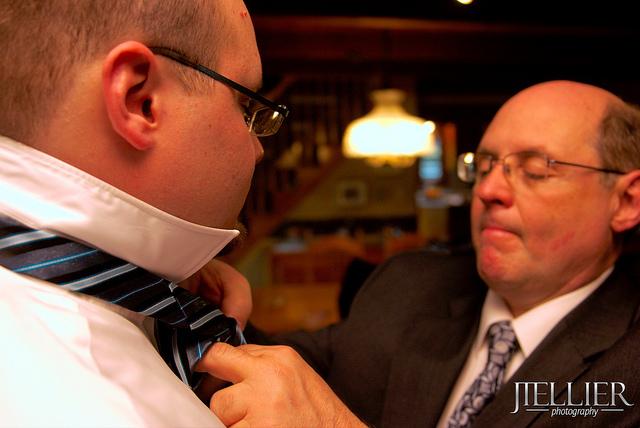Is the older man helping the younger man to adjust his tie?
Short answer required. Yes. Does the building have more than one floor?
Concise answer only. Yes. What are the men wearing on their faces?
Keep it brief. Glasses. 